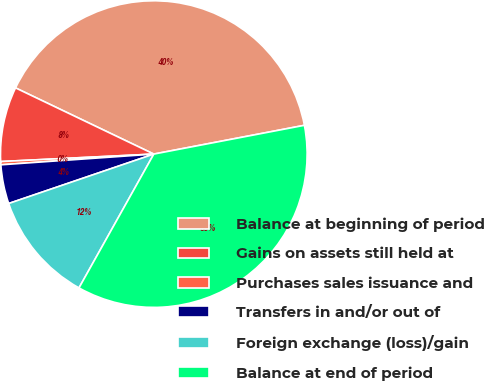<chart> <loc_0><loc_0><loc_500><loc_500><pie_chart><fcel>Balance at beginning of period<fcel>Gains on assets still held at<fcel>Purchases sales issuance and<fcel>Transfers in and/or out of<fcel>Foreign exchange (loss)/gain<fcel>Balance at end of period<nl><fcel>39.89%<fcel>7.88%<fcel>0.34%<fcel>4.11%<fcel>11.66%<fcel>36.12%<nl></chart> 